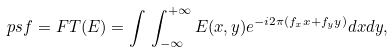Convert formula to latex. <formula><loc_0><loc_0><loc_500><loc_500>p s f = F T ( E ) = \int \, \int _ { - \infty } ^ { + \infty } E ( x , y ) { e } ^ { - i 2 \pi \left ( f _ { x } x + f _ { y } y \right ) } { d } x { d } y ,</formula> 